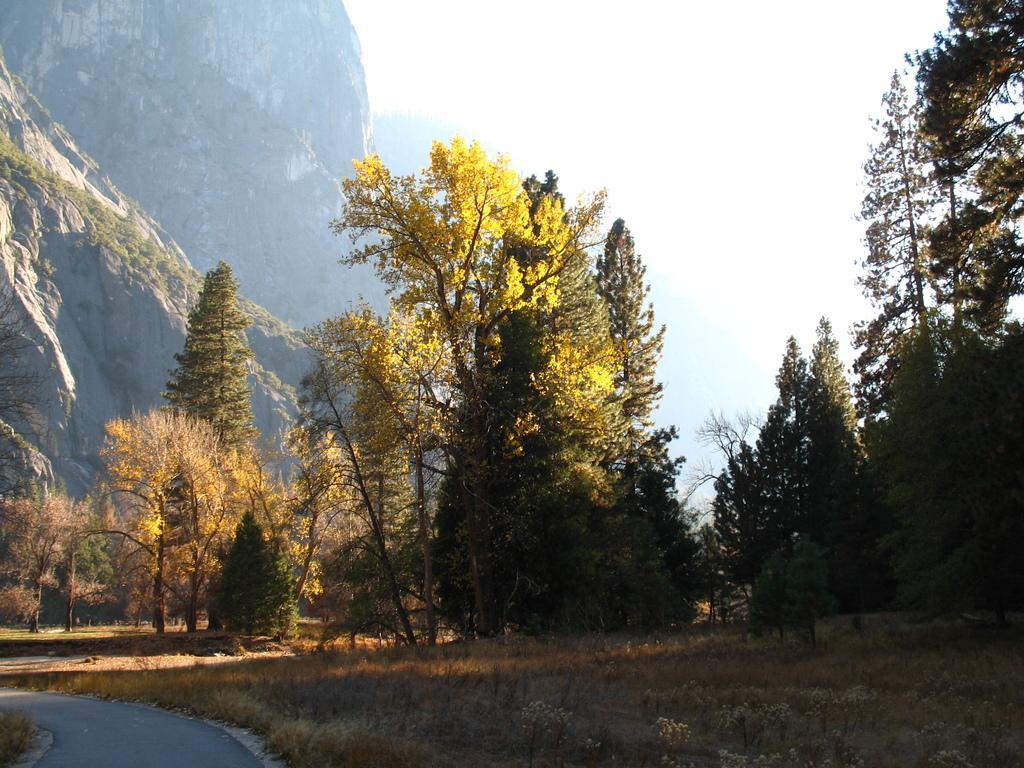Could you give a brief overview of what you see in this image? In the foreground of the picture there are plants, shrubs and road. In the center of the picture there are trees. On the left it is mountain. In the center of the background it is foggy. 